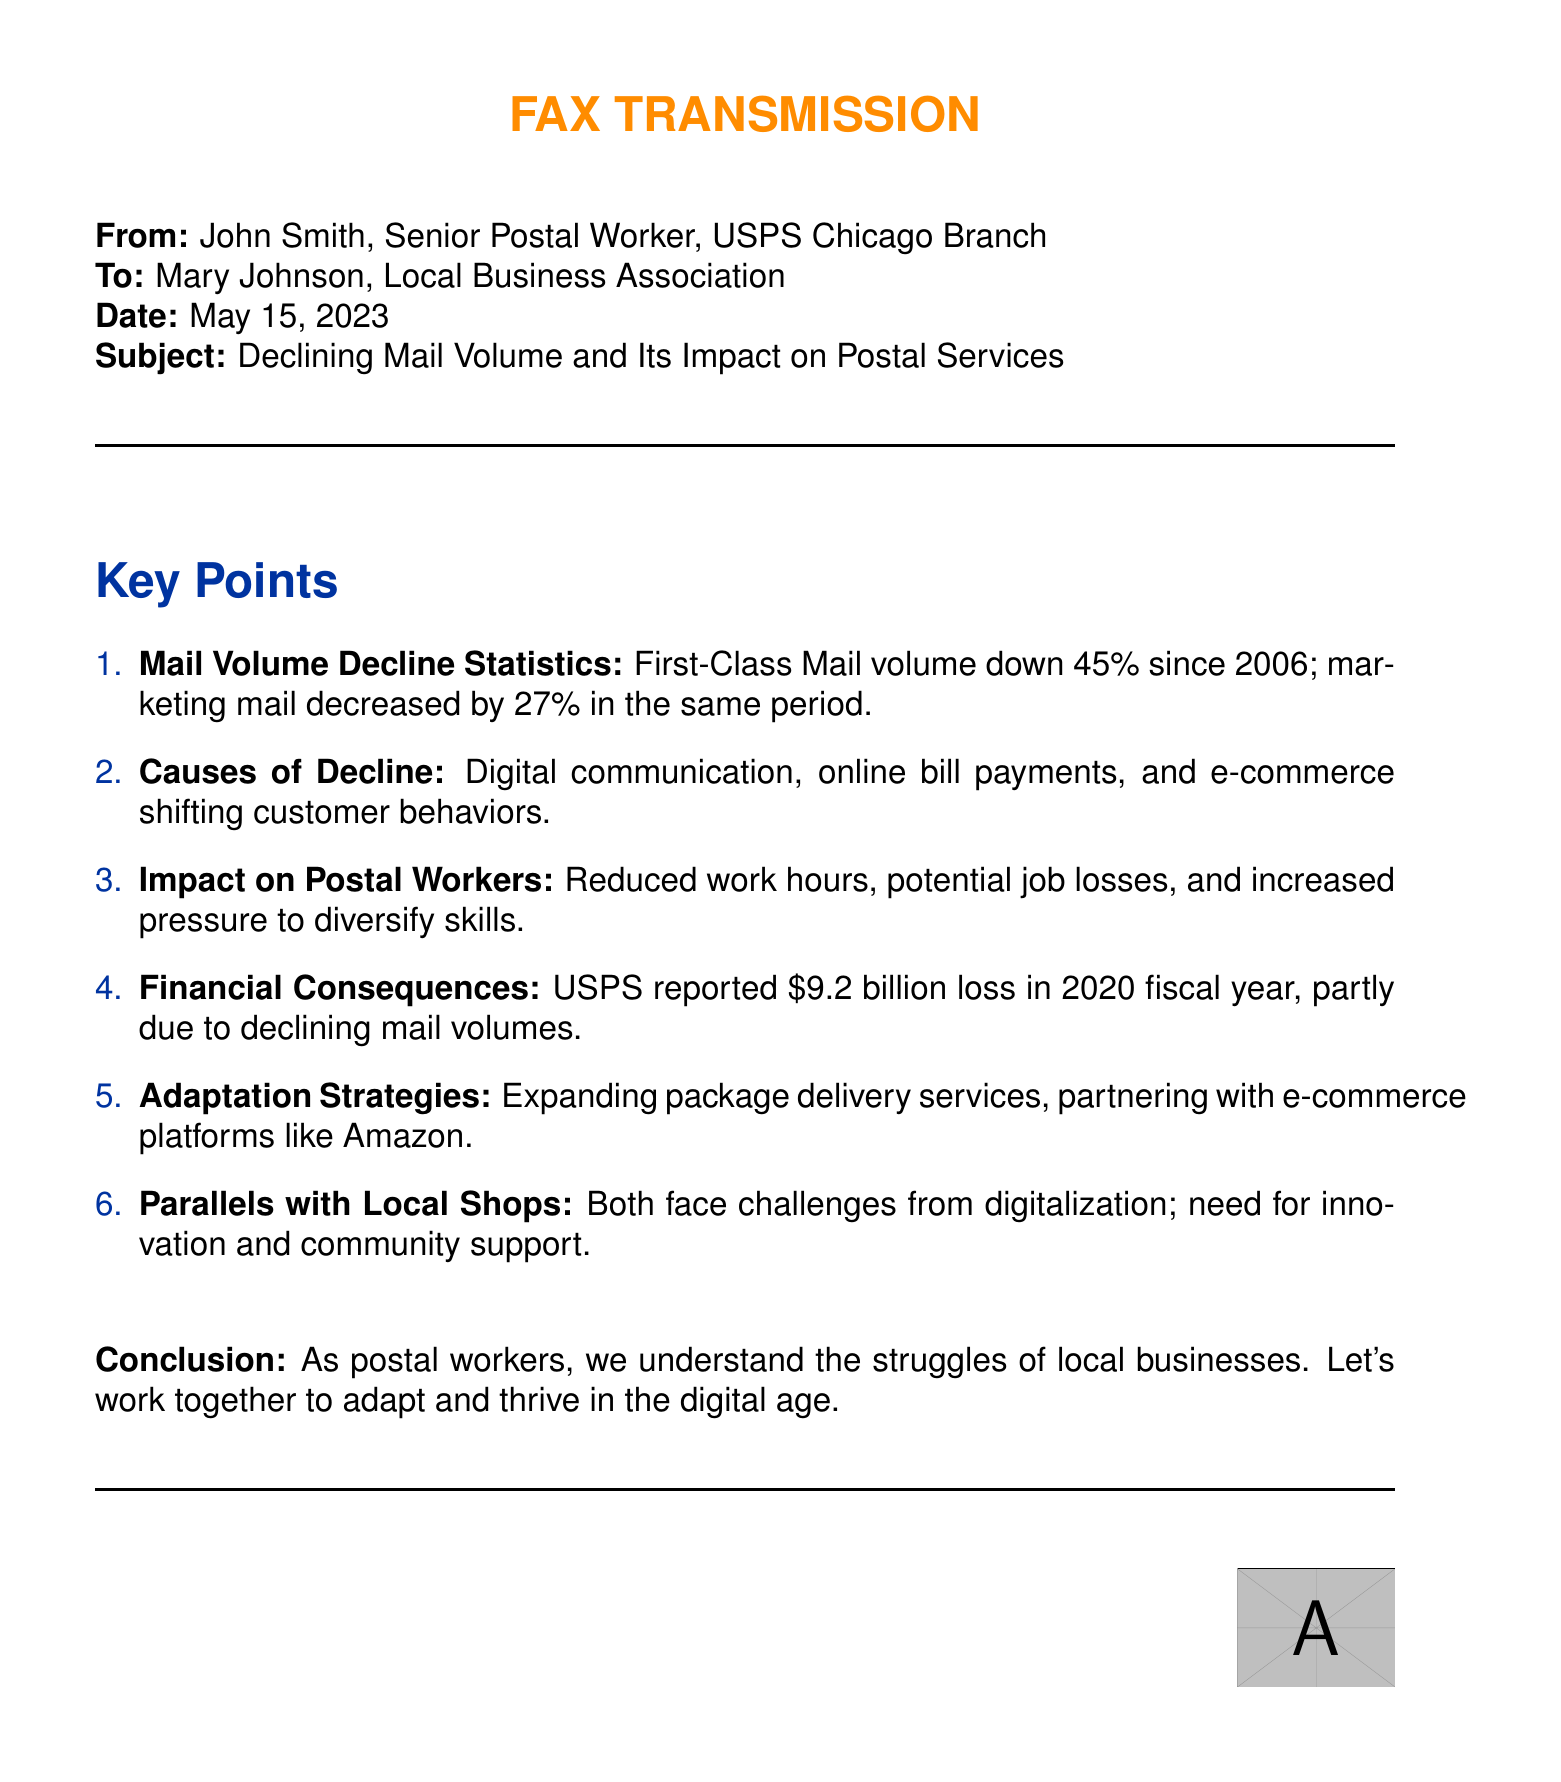what is the percentage decline for First-Class Mail since 2006? The document states that First-Class Mail volume is down 45% since 2006.
Answer: 45% what was the reported loss for USPS in the 2020 fiscal year? The document mentions USPS reported a \$9.2 billion loss in the 2020 fiscal year.
Answer: \$9.2 billion who sent the fax? The document indicates that the fax was sent by John Smith, Senior Postal Worker, USPS Chicago Branch.
Answer: John Smith what is one of the adaptation strategies mentioned? The document lists adapting by expanding package delivery services as one of the strategies.
Answer: Expanding package delivery services what impact does declining mail volume have on postal workers? According to the document, the impact includes reduced work hours and potential job losses.
Answer: Reduced work hours, potential job losses what are some causes of the decline in mail volume? The document lists digital communication and online bill payments as causes of the decline.
Answer: Digital communication, online bill payments how does the document relate to local shops? The document highlights parallels, indicating both face challenges from digitalization.
Answer: Both face challenges from digitalization what is the date of the fax? The document states that the fax was dated May 15, 2023.
Answer: May 15, 2023 what color is used for the section headings in the document? The document uses postal blue for the section headings.
Answer: Postal blue 